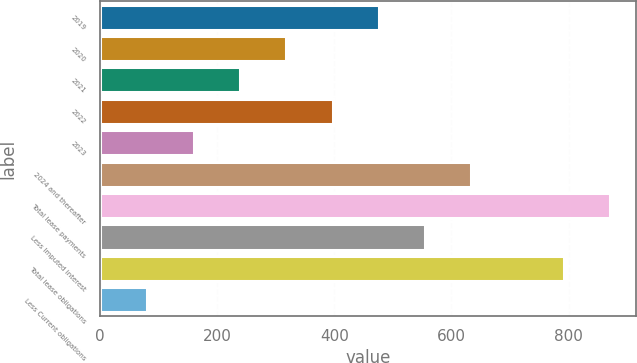<chart> <loc_0><loc_0><loc_500><loc_500><bar_chart><fcel>2019<fcel>2020<fcel>2021<fcel>2022<fcel>2023<fcel>2024 and thereafter<fcel>Total lease payments<fcel>Less Imputed interest<fcel>Total lease obligations<fcel>Less Current obligations<nl><fcel>476<fcel>318<fcel>239<fcel>397<fcel>160<fcel>634<fcel>871<fcel>555<fcel>792<fcel>81<nl></chart> 